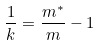Convert formula to latex. <formula><loc_0><loc_0><loc_500><loc_500>\frac { 1 } { k } = \frac { m ^ { * } } { m } - 1</formula> 